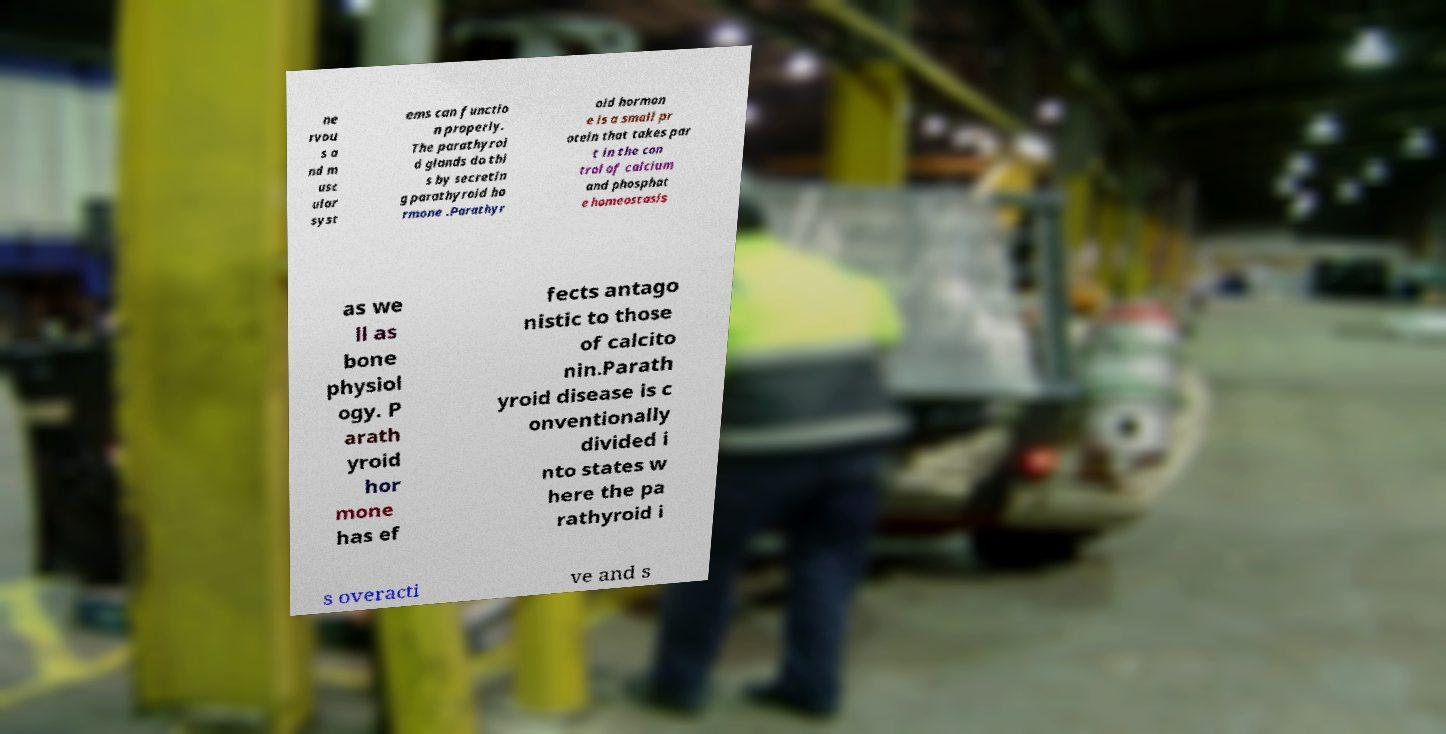Can you read and provide the text displayed in the image?This photo seems to have some interesting text. Can you extract and type it out for me? ne rvou s a nd m usc ular syst ems can functio n properly. The parathyroi d glands do thi s by secretin g parathyroid ho rmone .Parathyr oid hormon e is a small pr otein that takes par t in the con trol of calcium and phosphat e homeostasis as we ll as bone physiol ogy. P arath yroid hor mone has ef fects antago nistic to those of calcito nin.Parath yroid disease is c onventionally divided i nto states w here the pa rathyroid i s overacti ve and s 